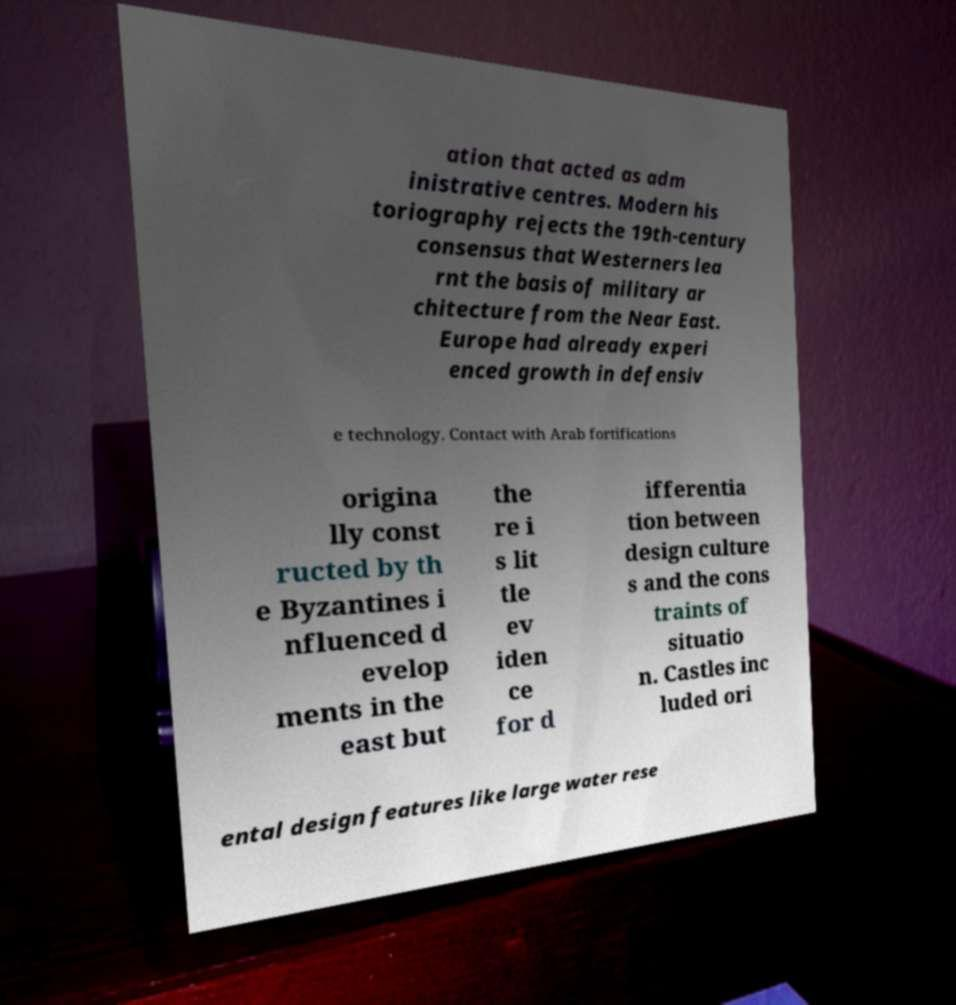Could you assist in decoding the text presented in this image and type it out clearly? ation that acted as adm inistrative centres. Modern his toriography rejects the 19th-century consensus that Westerners lea rnt the basis of military ar chitecture from the Near East. Europe had already experi enced growth in defensiv e technology. Contact with Arab fortifications origina lly const ructed by th e Byzantines i nfluenced d evelop ments in the east but the re i s lit tle ev iden ce for d ifferentia tion between design culture s and the cons traints of situatio n. Castles inc luded ori ental design features like large water rese 